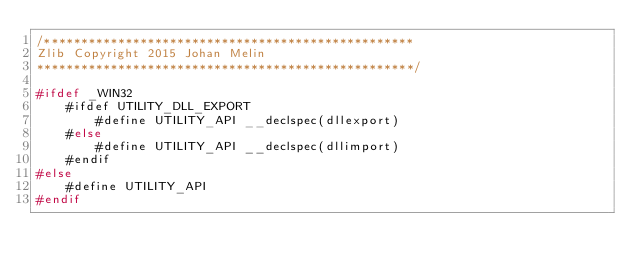Convert code to text. <code><loc_0><loc_0><loc_500><loc_500><_C_>/**************************************************
Zlib Copyright 2015 Johan Melin
***************************************************/

#ifdef _WIN32
	#ifdef UTILITY_DLL_EXPORT
		#define UTILITY_API __declspec(dllexport)
	#else
		#define UTILITY_API __declspec(dllimport)
	#endif
#else
	#define UTILITY_API
#endif
</code> 